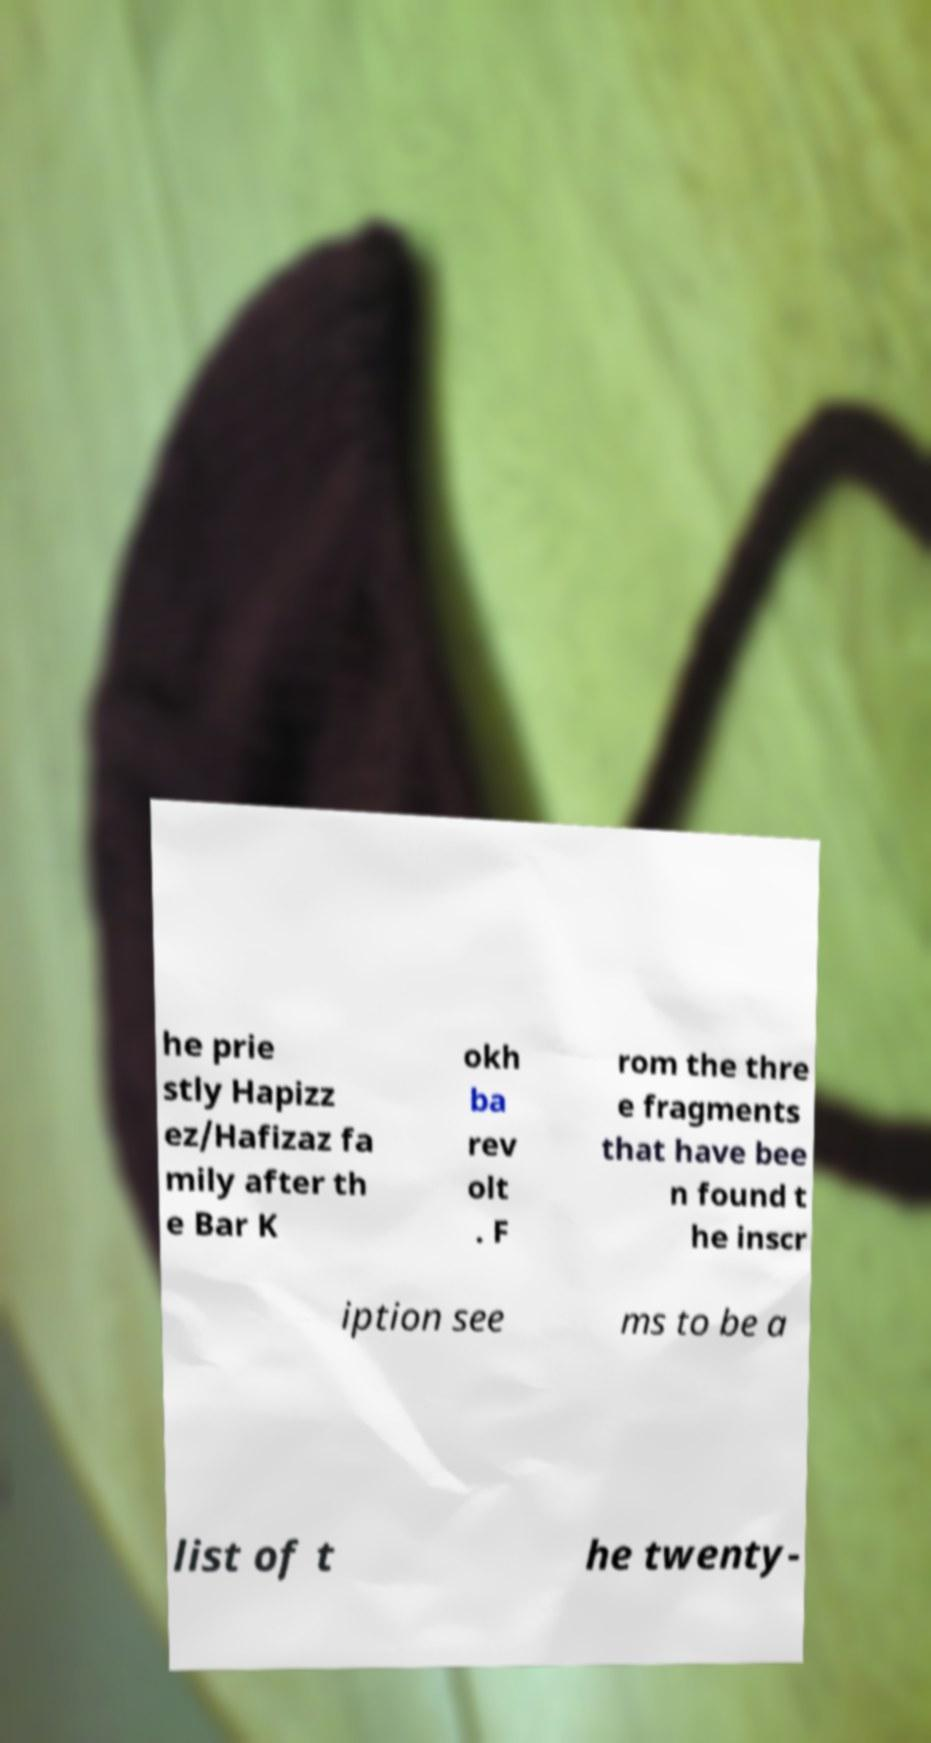What messages or text are displayed in this image? I need them in a readable, typed format. he prie stly Hapizz ez/Hafizaz fa mily after th e Bar K okh ba rev olt . F rom the thre e fragments that have bee n found t he inscr iption see ms to be a list of t he twenty- 